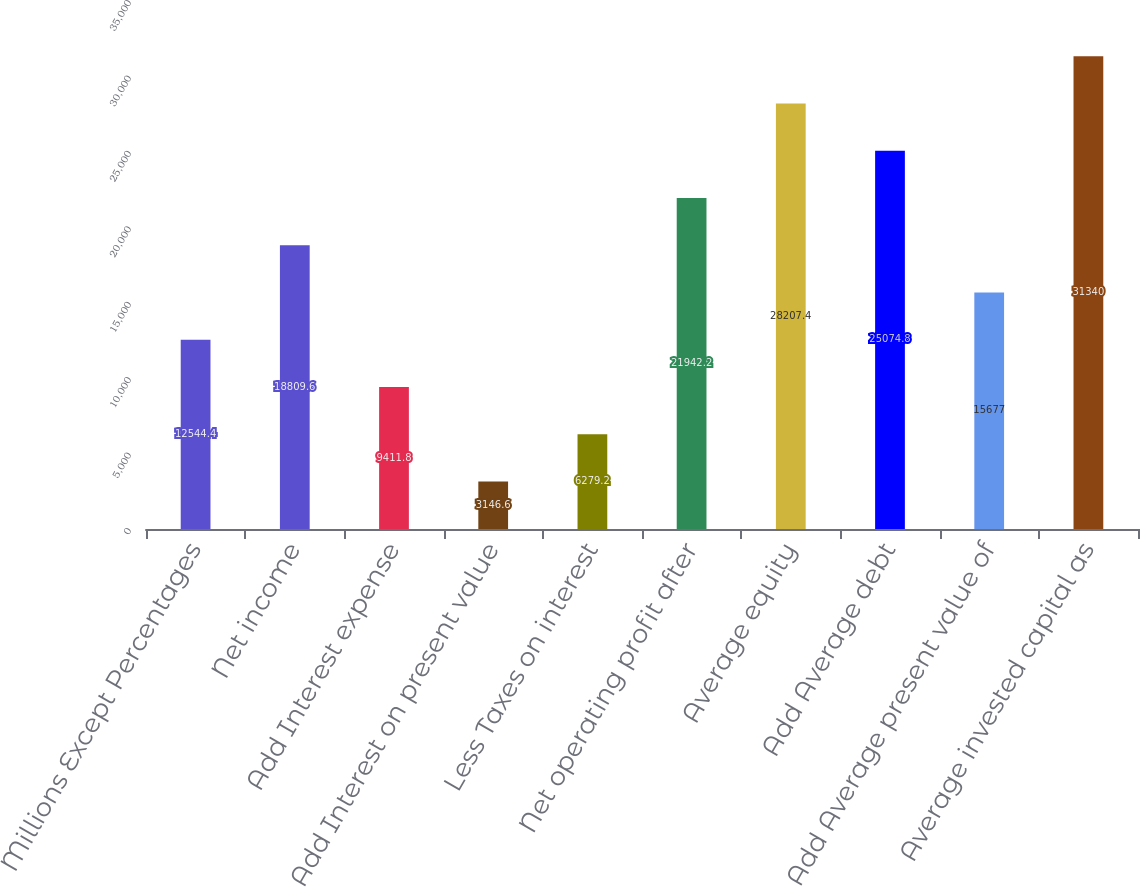Convert chart to OTSL. <chart><loc_0><loc_0><loc_500><loc_500><bar_chart><fcel>Millions Except Percentages<fcel>Net income<fcel>Add Interest expense<fcel>Add Interest on present value<fcel>Less Taxes on interest<fcel>Net operating profit after<fcel>Average equity<fcel>Add Average debt<fcel>Add Average present value of<fcel>Average invested capital as<nl><fcel>12544.4<fcel>18809.6<fcel>9411.8<fcel>3146.6<fcel>6279.2<fcel>21942.2<fcel>28207.4<fcel>25074.8<fcel>15677<fcel>31340<nl></chart> 